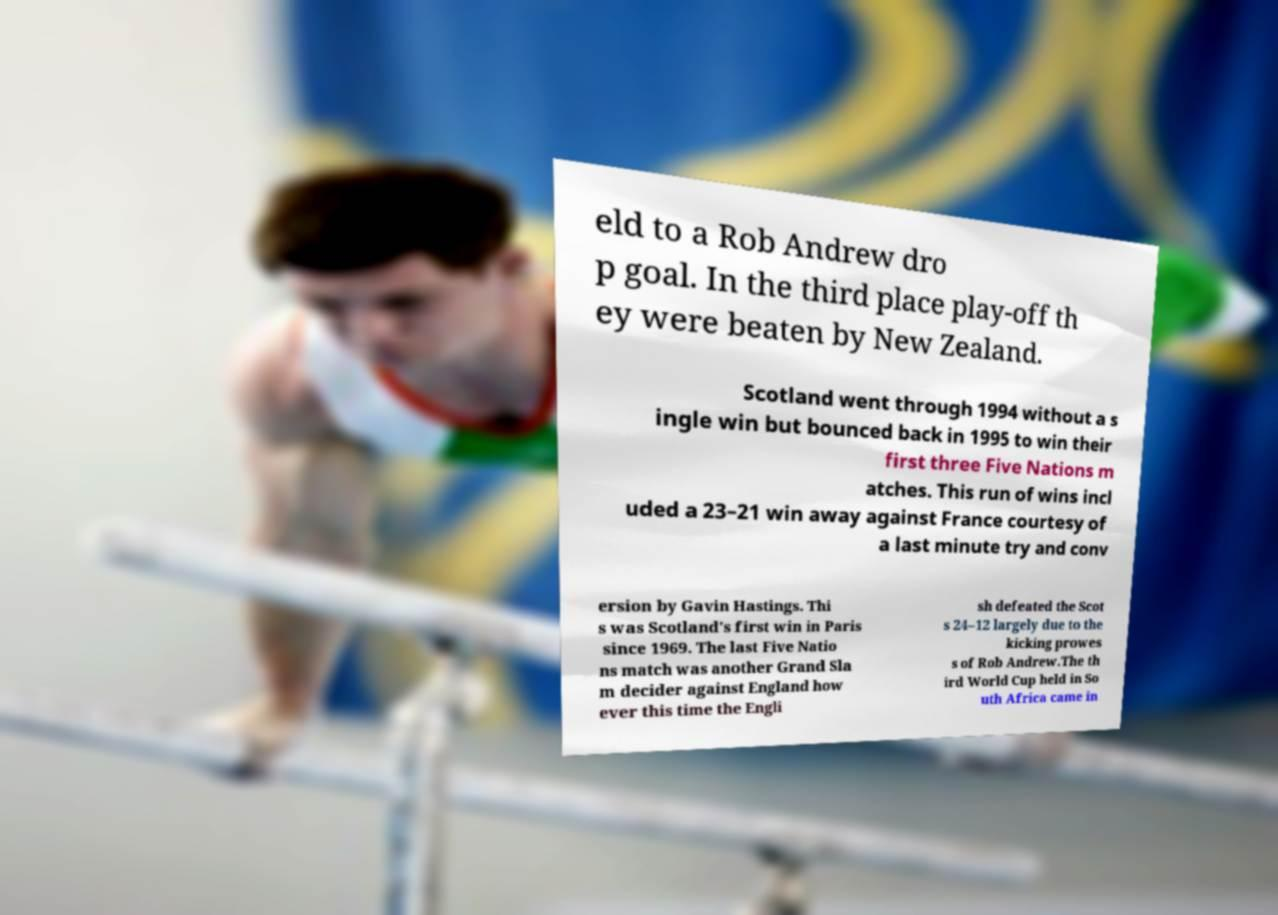I need the written content from this picture converted into text. Can you do that? eld to a Rob Andrew dro p goal. In the third place play-off th ey were beaten by New Zealand. Scotland went through 1994 without a s ingle win but bounced back in 1995 to win their first three Five Nations m atches. This run of wins incl uded a 23–21 win away against France courtesy of a last minute try and conv ersion by Gavin Hastings. Thi s was Scotland's first win in Paris since 1969. The last Five Natio ns match was another Grand Sla m decider against England how ever this time the Engli sh defeated the Scot s 24–12 largely due to the kicking prowes s of Rob Andrew.The th ird World Cup held in So uth Africa came in 